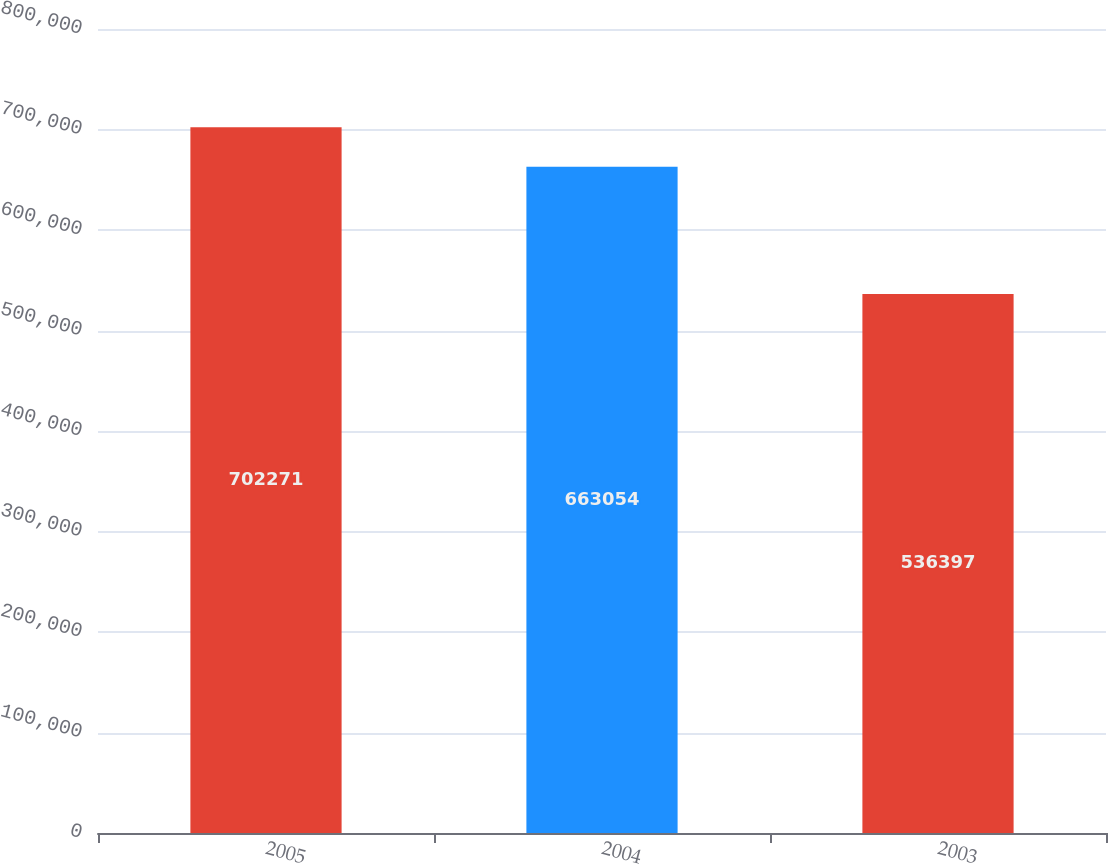Convert chart to OTSL. <chart><loc_0><loc_0><loc_500><loc_500><bar_chart><fcel>2005<fcel>2004<fcel>2003<nl><fcel>702271<fcel>663054<fcel>536397<nl></chart> 